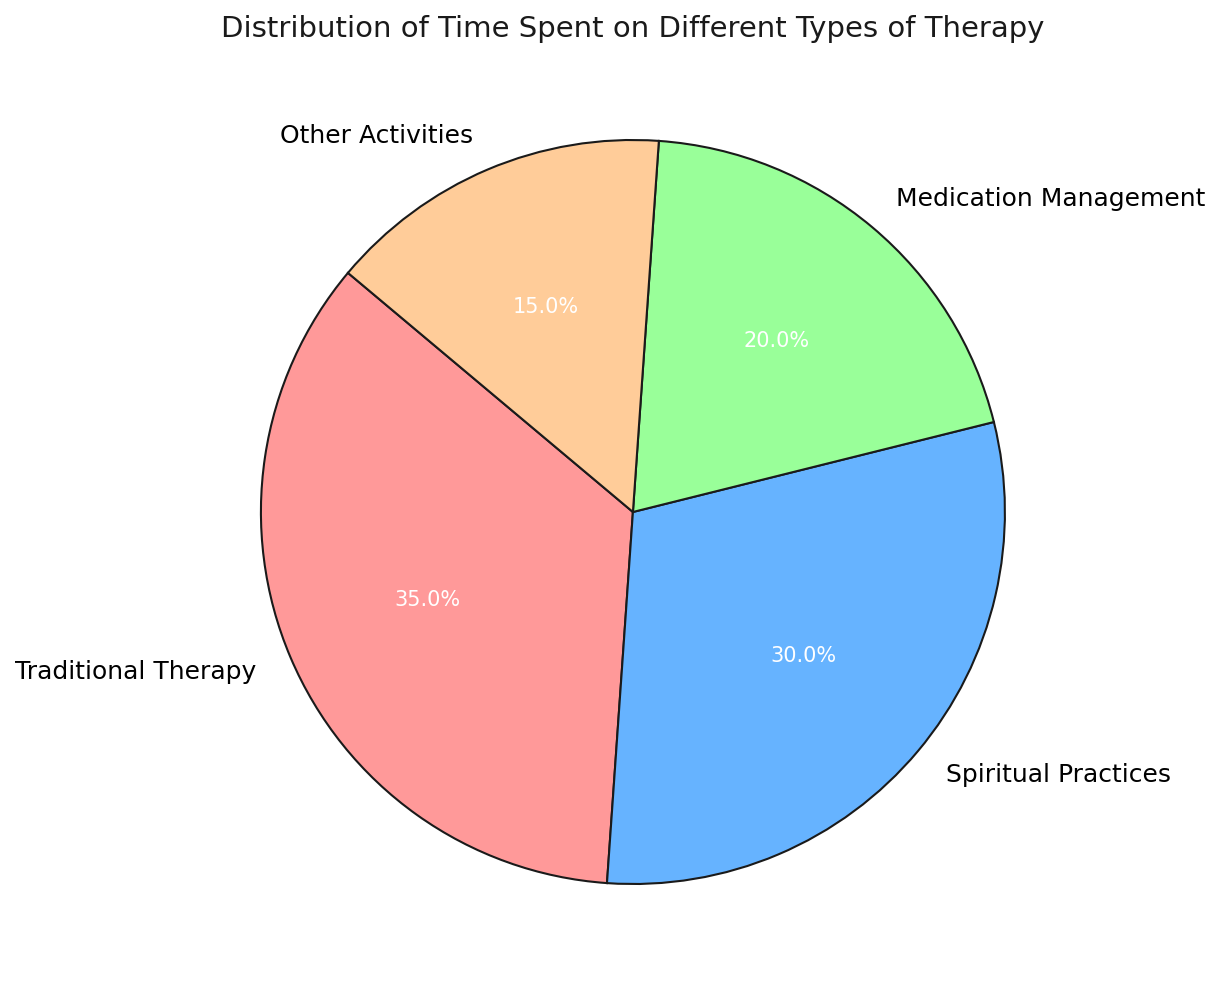What's the largest segment in the pie chart? By examining the sizes of the segments, the largest one appears to be labeled as "Traditional Therapy" which takes up a considerable portion of the entire pie chart.
Answer: Traditional Therapy Which activity takes up less time, Medication Management or Other Activities? By comparing the sizes of the segments labeled as "Medication Management" and "Other Activities," "Other Activities" takes up less time.
Answer: Other Activities How much more time is spent on Traditional Therapy than on Medication Management? The chart shows that 35% of the time is spent on Traditional Therapy and 20% on Medication Management. The difference is calculated as 35% - 20% = 15%.
Answer: 15% What fraction of the pie chart is dedicated to Spiritual Practices? The segment labeled "Spiritual Practices" accounts for 30% of the pie chart, which can be represented as the fraction 30/100 or simplified to 3/10.
Answer: 3/10 Which activities combined take up more than half of the pie chart? Adding the percentages for Traditional Therapy (35%) and Spiritual Practices (30%) results in 35% + 30% = 65%, which is more than half of the pie chart.
Answer: Traditional Therapy and Spiritual Practices If the total time spent is 100 hours, how many hours are dedicated to Other Activities? Given that 15% of the time is dedicated to Other Activities, 15% of 100 hours is calculated as 15/100 * 100 = 15 hours.
Answer: 15 hours Which is the second-largest segment in the pie chart? By visually inspecting the sizes of the segments, the second-largest segment is labeled as "Spiritual Practices," which occupies 30% of the pie chart.
Answer: Spiritual Practices How does the time spent on Traditional Therapy compare to the combined time spent on Medication Management and Other Activities? The time spent on Traditional Therapy is 35% while the combined time for Medication Management (20%) and Other Activities (15%) is 20% + 15% = 35%. They are equal.
Answer: Equal What's the percentage difference between the smallest and the largest segments? The smallest segment, "Other Activities," is 15%, and the largest, "Traditional Therapy," is 35%. The percentage difference is calculated as (35% - 15%) = 20%.
Answer: 20% 